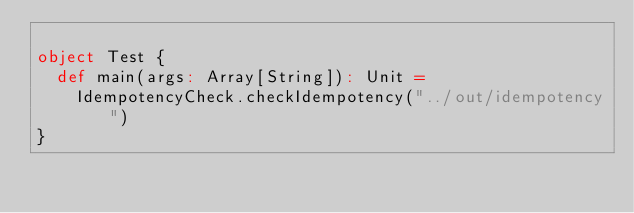<code> <loc_0><loc_0><loc_500><loc_500><_Scala_>
object Test {
  def main(args: Array[String]): Unit =
    IdempotencyCheck.checkIdempotency("../out/idempotency")
}
</code> 